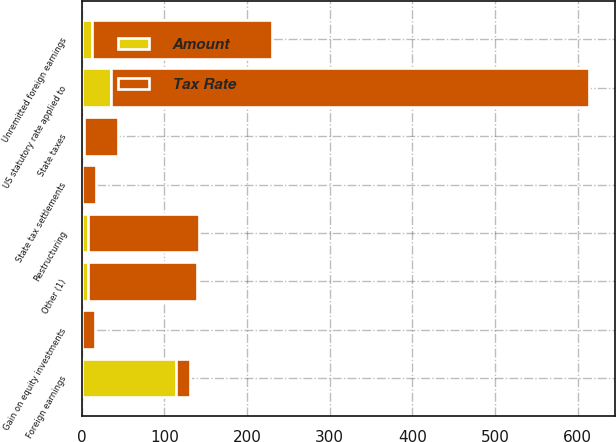Convert chart to OTSL. <chart><loc_0><loc_0><loc_500><loc_500><stacked_bar_chart><ecel><fcel>US statutory rate applied to<fcel>Foreign earnings<fcel>Unremitted foreign earnings<fcel>State taxes<fcel>State tax settlements<fcel>Restructuring<fcel>Gain on equity investments<fcel>Other (1)<nl><fcel>Tax Rate<fcel>579<fcel>17<fcel>217<fcel>42<fcel>17<fcel>134<fcel>15<fcel>131<nl><fcel>Amount<fcel>35<fcel>113.6<fcel>13.1<fcel>2.6<fcel>1<fcel>8.1<fcel>0.9<fcel>8<nl></chart> 